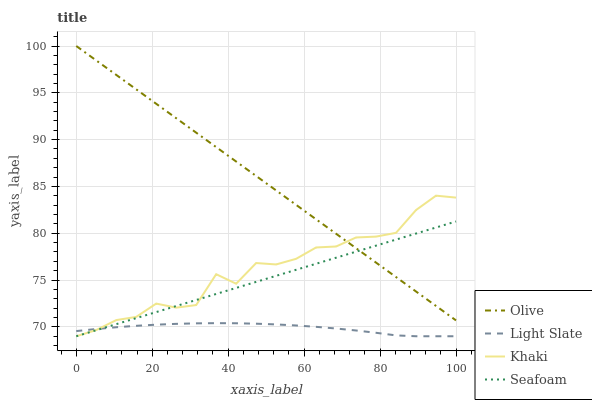Does Light Slate have the minimum area under the curve?
Answer yes or no. Yes. Does Olive have the maximum area under the curve?
Answer yes or no. Yes. Does Khaki have the minimum area under the curve?
Answer yes or no. No. Does Khaki have the maximum area under the curve?
Answer yes or no. No. Is Olive the smoothest?
Answer yes or no. Yes. Is Khaki the roughest?
Answer yes or no. Yes. Is Light Slate the smoothest?
Answer yes or no. No. Is Light Slate the roughest?
Answer yes or no. No. Does Light Slate have the lowest value?
Answer yes or no. Yes. Does Olive have the highest value?
Answer yes or no. Yes. Does Khaki have the highest value?
Answer yes or no. No. Is Light Slate less than Olive?
Answer yes or no. Yes. Is Olive greater than Light Slate?
Answer yes or no. Yes. Does Seafoam intersect Light Slate?
Answer yes or no. Yes. Is Seafoam less than Light Slate?
Answer yes or no. No. Is Seafoam greater than Light Slate?
Answer yes or no. No. Does Light Slate intersect Olive?
Answer yes or no. No. 